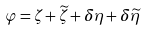Convert formula to latex. <formula><loc_0><loc_0><loc_500><loc_500>\varphi = \zeta + \widetilde { \zeta } + \delta \eta + \delta \widetilde { \eta }</formula> 